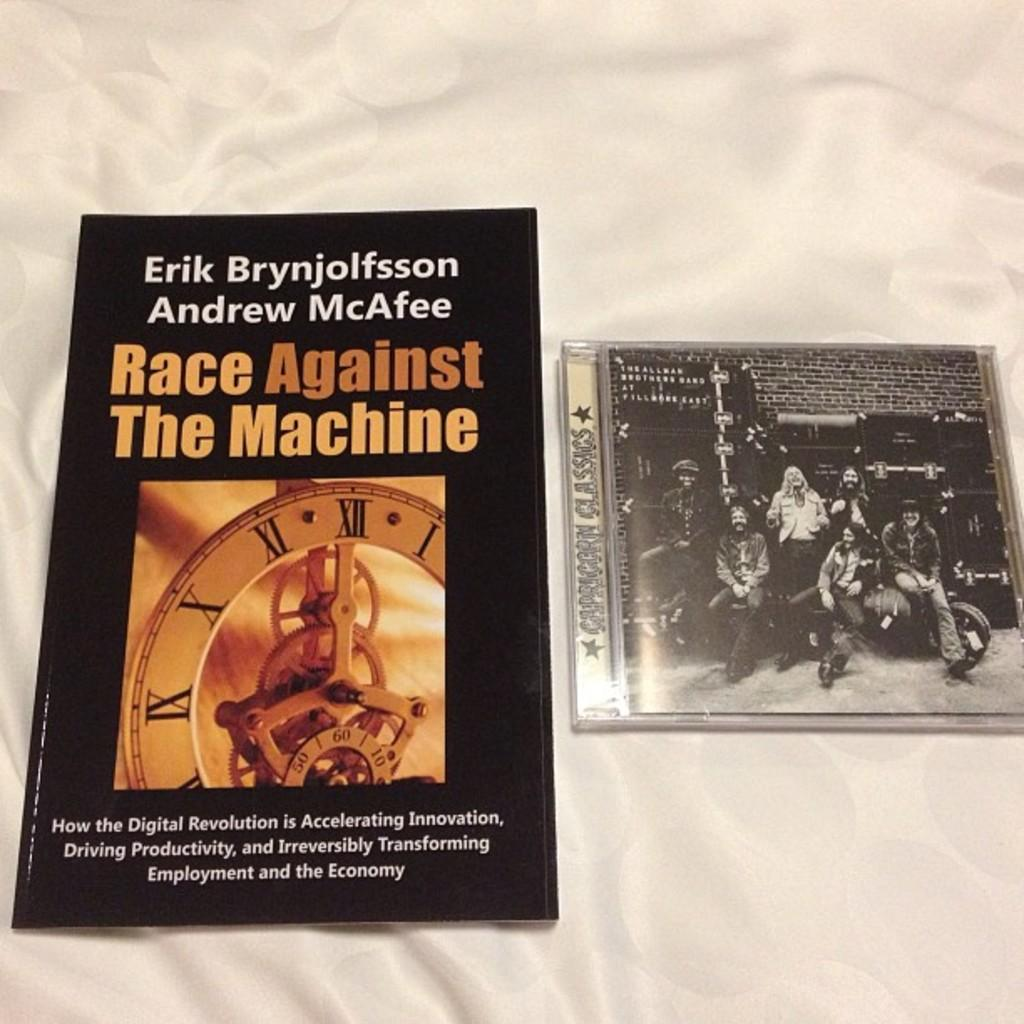<image>
Relay a brief, clear account of the picture shown. a book that says 'race against the machine' on it 